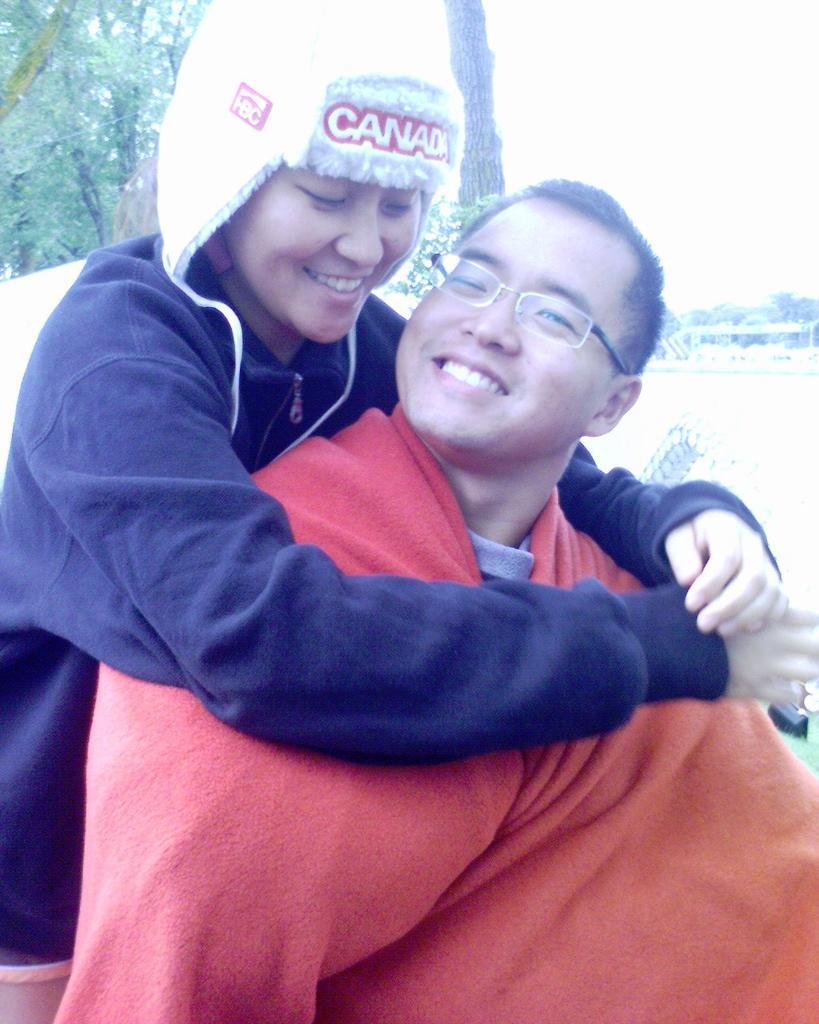How would you summarize this image in a sentence or two? In this picture there are two people smiling. At the back there are trees. At the top there is sky. At the bottom there is grass. 